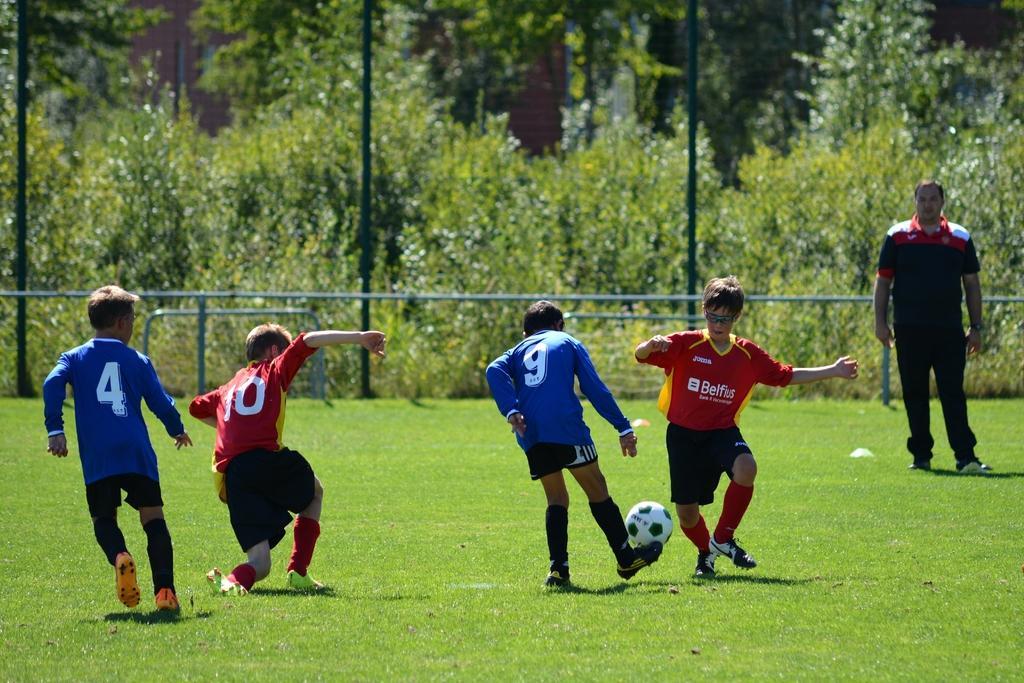How would you summarize this image in a sentence or two? This image is taken outdoors. At the bottom of the image there is a ground with grass on it. In the background there is a railing. There are many trees and plants. There are a few poles. On the right side of the image a man is standing on the ground. In the middle of the image four boys are playing football with a ball. 